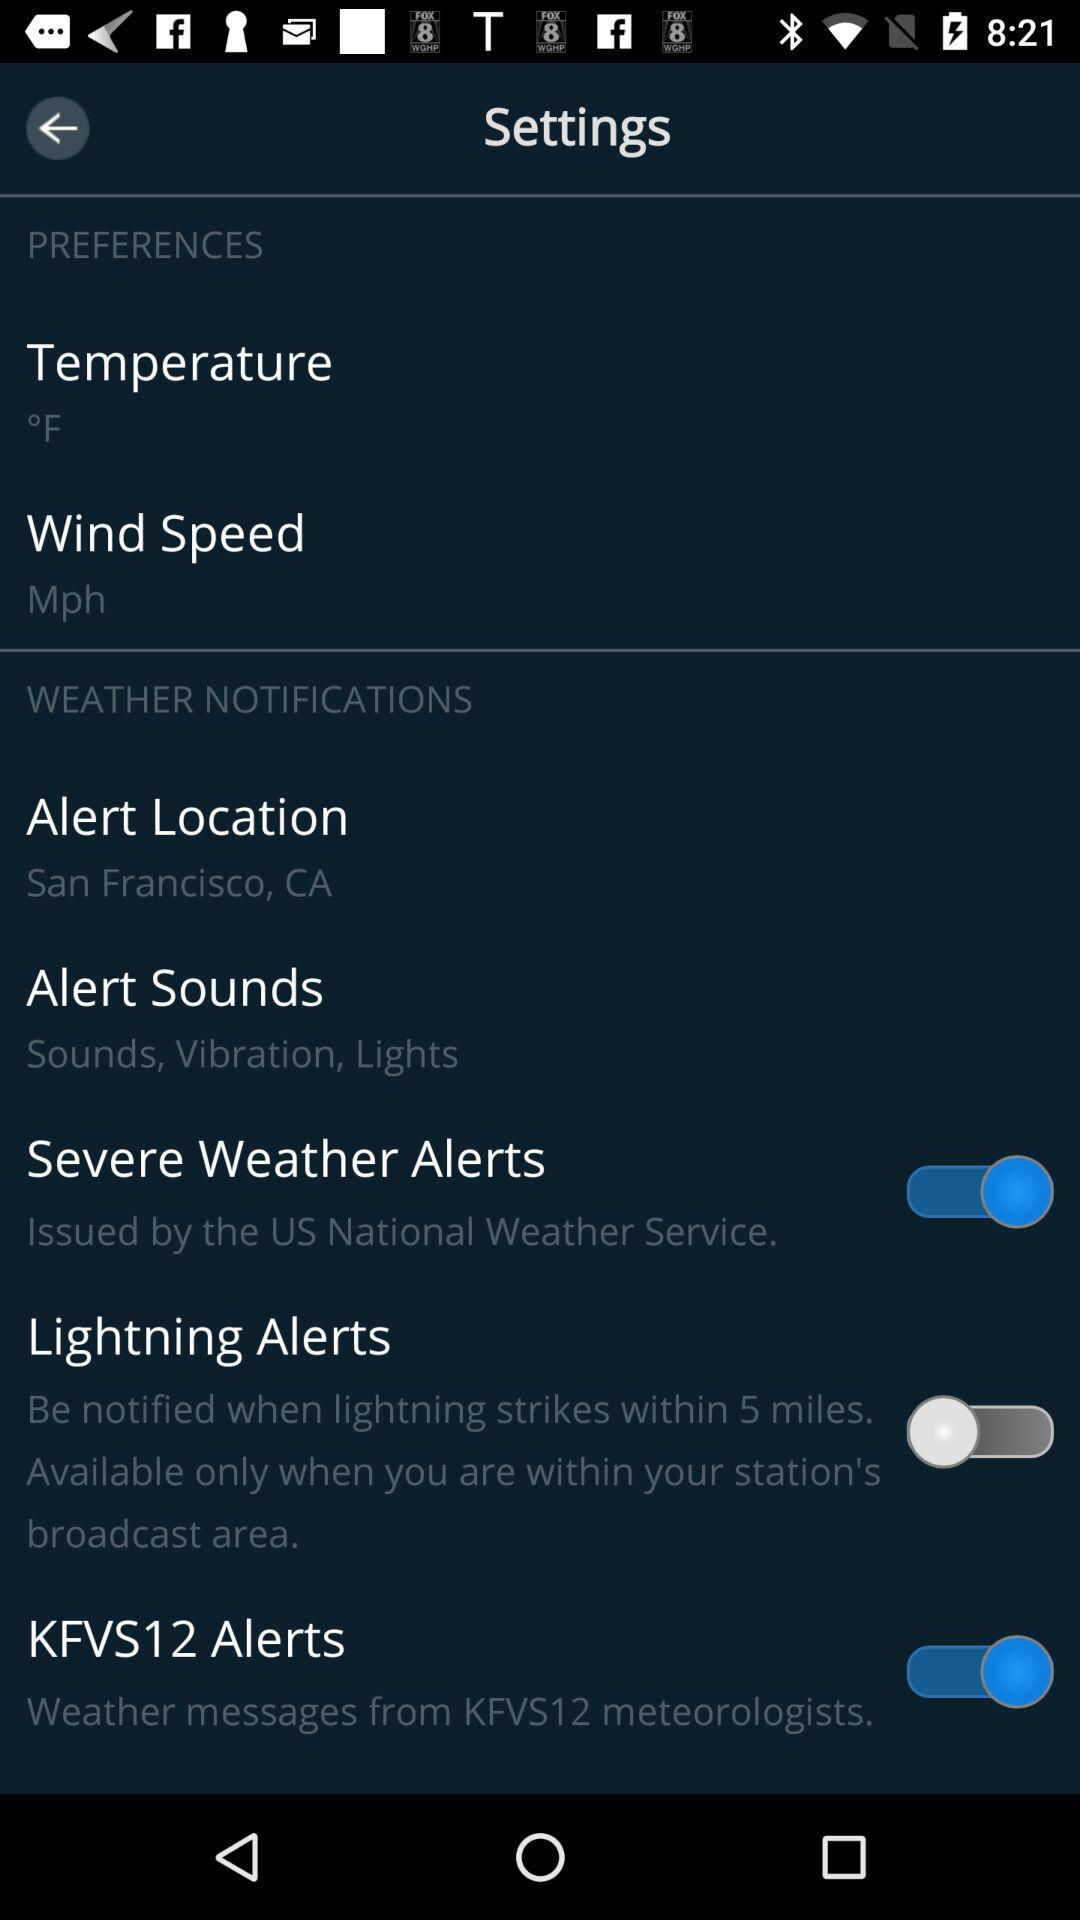From what distance do lightning alerts originate? Lightning alerts originate within 5 miles. 